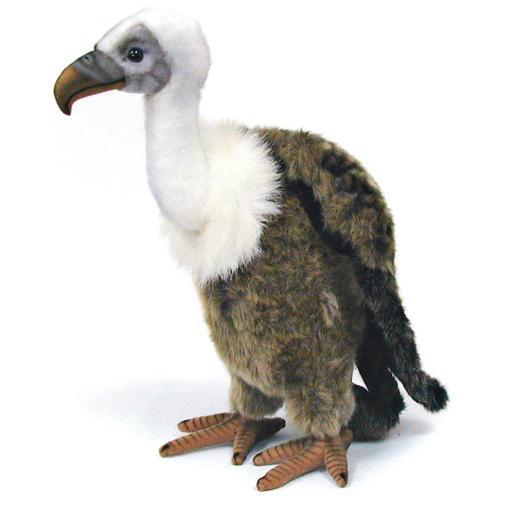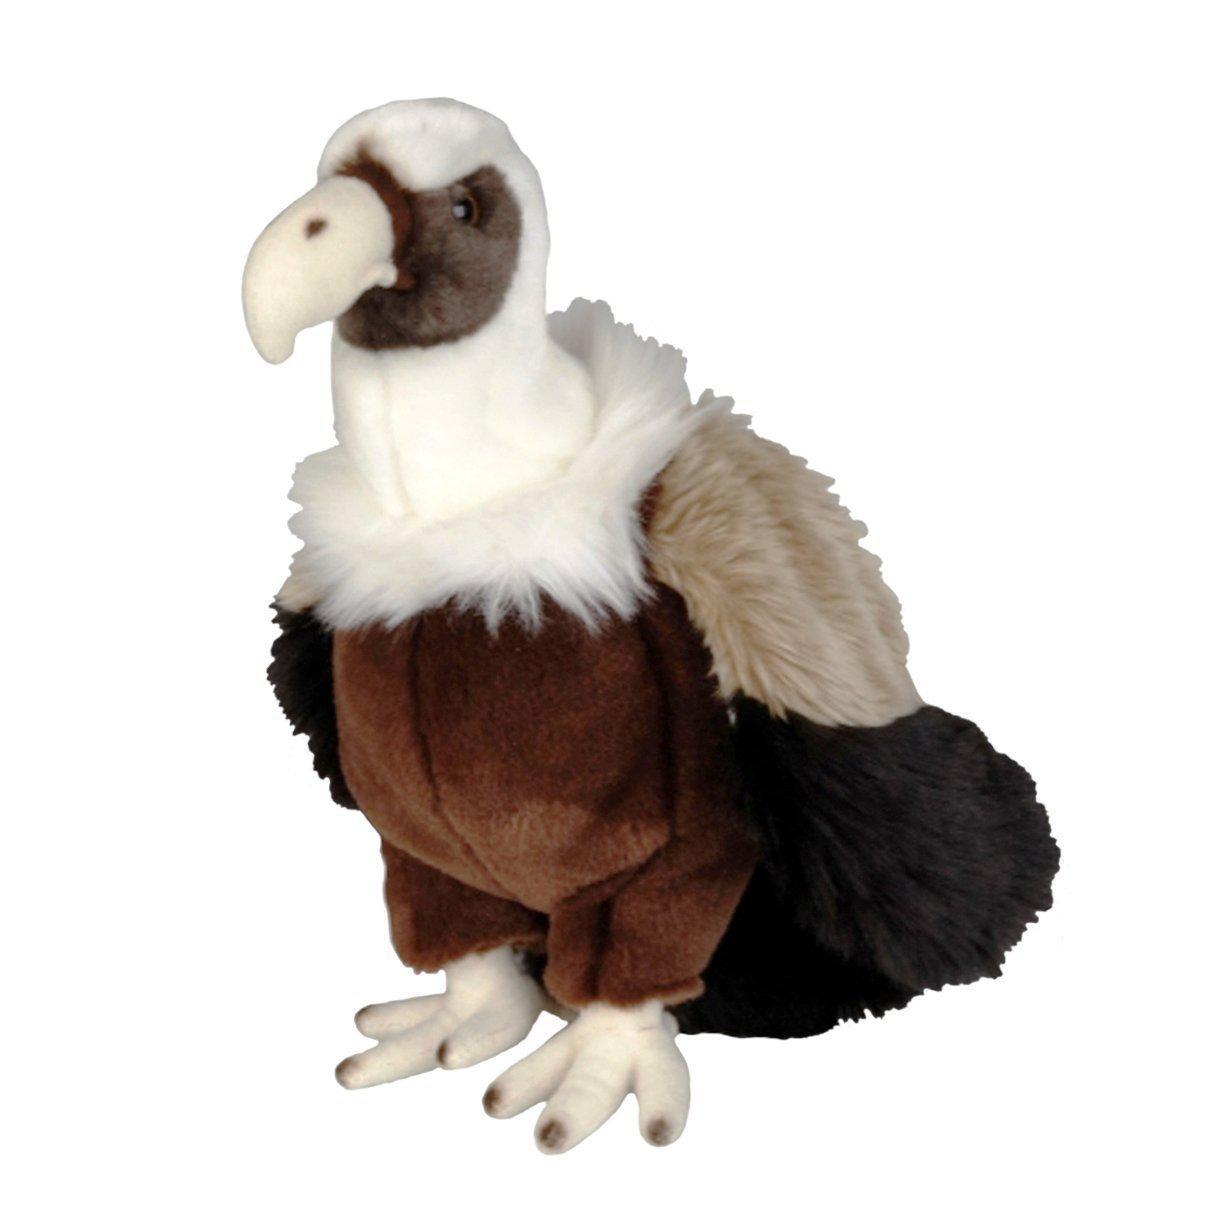The first image is the image on the left, the second image is the image on the right. Analyze the images presented: Is the assertion "1 bird is facing left and 1 bird is facing right." valid? Answer yes or no. No. 